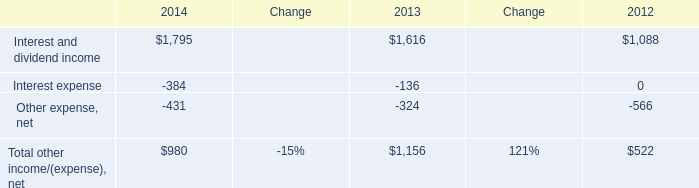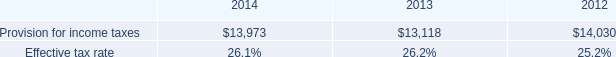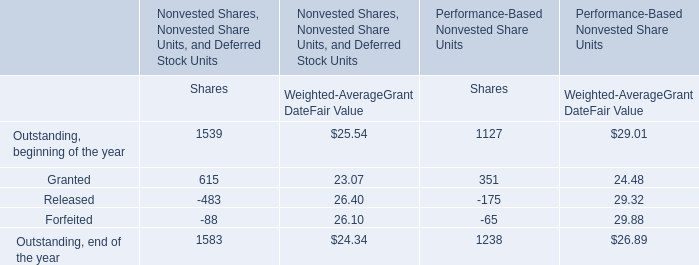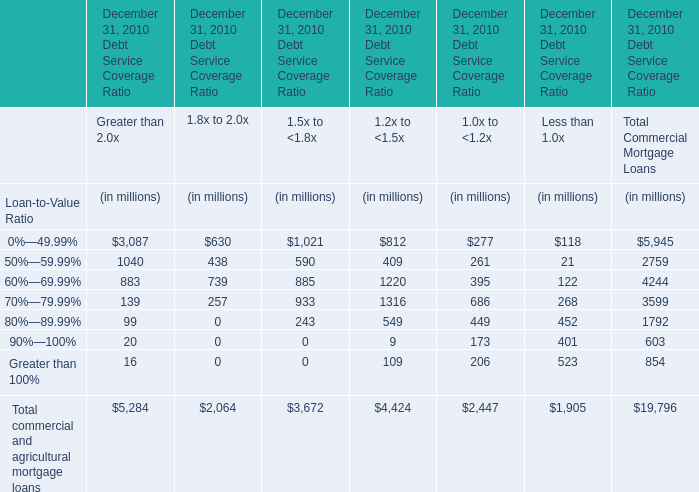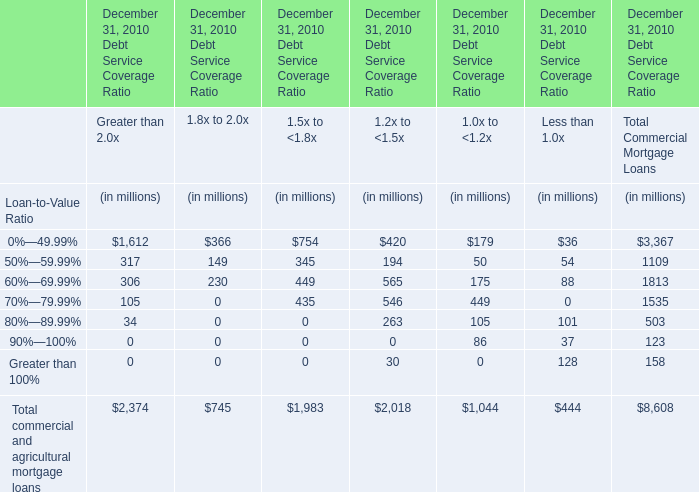What's the average of Interest and dividend income of 2013, and Provision for income taxes of 2014 ? 
Computations: ((1616.0 + 13973.0) / 2)
Answer: 7794.5. 